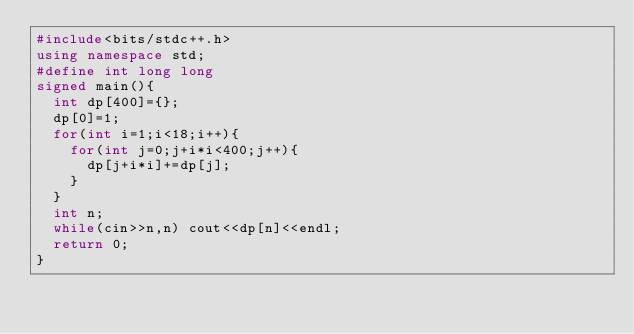<code> <loc_0><loc_0><loc_500><loc_500><_C++_>#include<bits/stdc++.h>
using namespace std;
#define int long long
signed main(){
  int dp[400]={};
  dp[0]=1;
  for(int i=1;i<18;i++){
    for(int j=0;j+i*i<400;j++){
      dp[j+i*i]+=dp[j];
    }
  }
  int n;
  while(cin>>n,n) cout<<dp[n]<<endl;
  return 0;
}</code> 